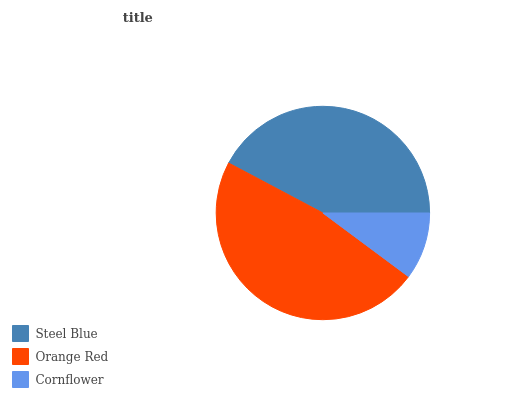Is Cornflower the minimum?
Answer yes or no. Yes. Is Orange Red the maximum?
Answer yes or no. Yes. Is Orange Red the minimum?
Answer yes or no. No. Is Cornflower the maximum?
Answer yes or no. No. Is Orange Red greater than Cornflower?
Answer yes or no. Yes. Is Cornflower less than Orange Red?
Answer yes or no. Yes. Is Cornflower greater than Orange Red?
Answer yes or no. No. Is Orange Red less than Cornflower?
Answer yes or no. No. Is Steel Blue the high median?
Answer yes or no. Yes. Is Steel Blue the low median?
Answer yes or no. Yes. Is Orange Red the high median?
Answer yes or no. No. Is Orange Red the low median?
Answer yes or no. No. 